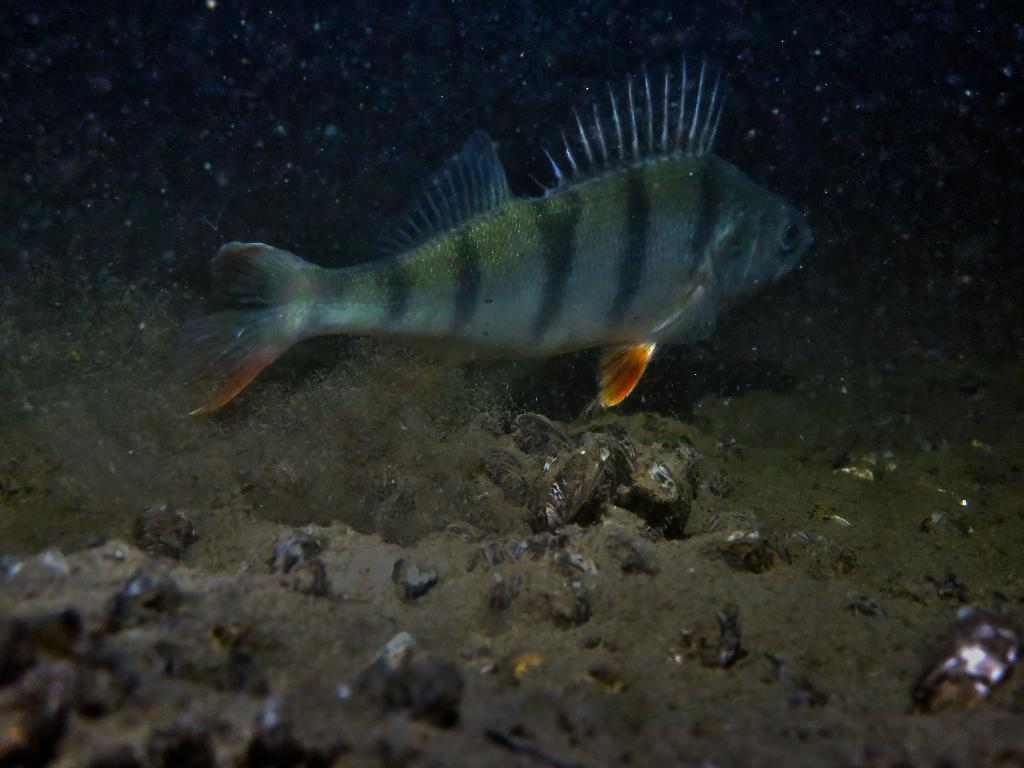What type of animals can be seen in the image? There are fish in the image. What are the fish doing in the image? The fish are swimming in the water. What type of territory do the fish claim in the image? There is no indication of territorial claims in the image; the fish are simply swimming in the water. 